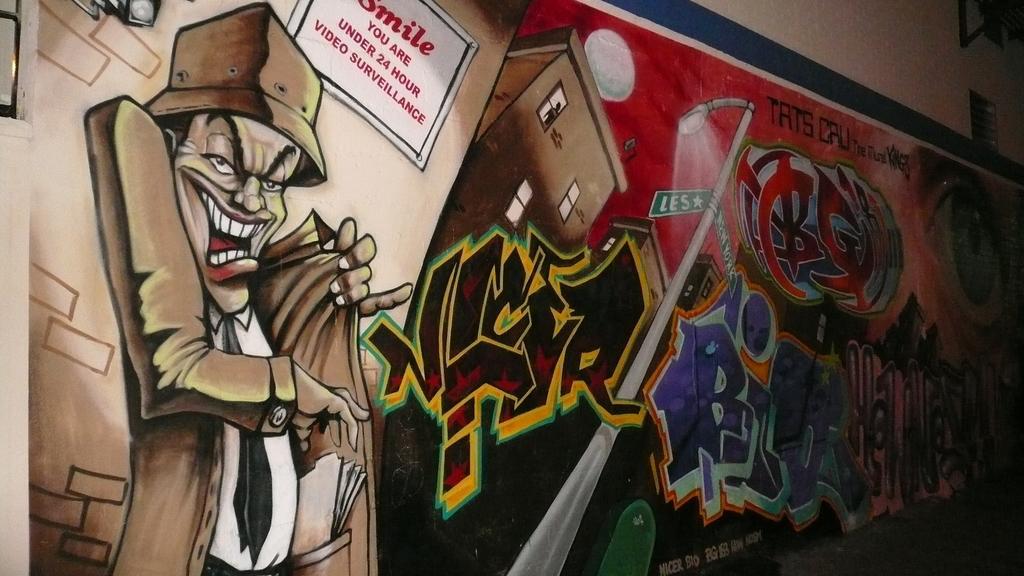Please provide a concise description of this image. On this hoarding there is a building, animated person and light pole. Something written on this hoarding. 